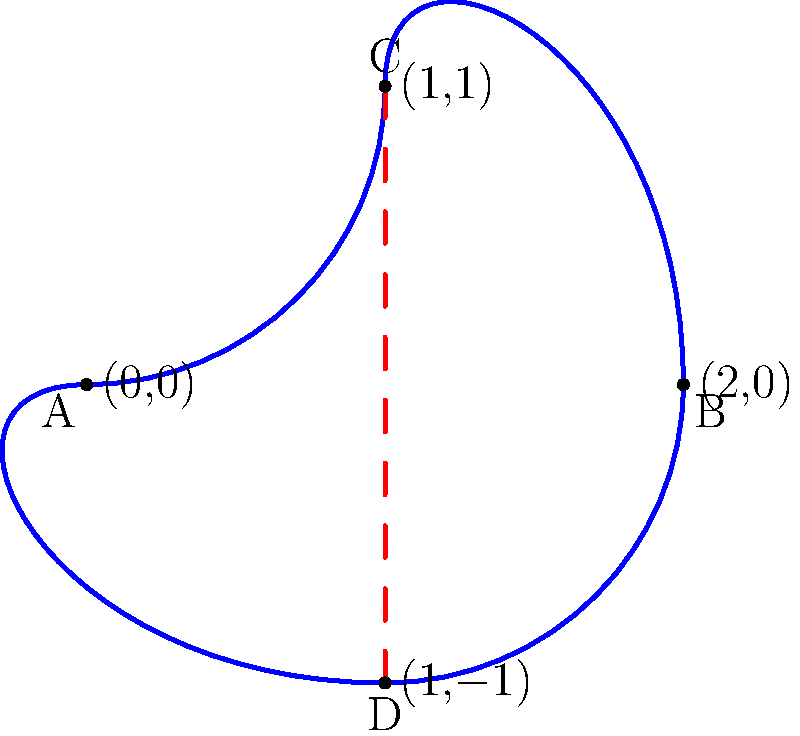In Moroccan literature, the concept of cultural identity is often explored through complex, interconnected narratives. This structure can be likened to a Klein bottle, a non-Euclidean surface without an inside or outside. Consider the 2D projection of a Klein bottle shown above. If we imagine a character's journey through a novel as a path on this surface, starting from point A and traveling clockwise, how many times must they cross the red dashed line to return to their starting point? Relate your answer to the idea of cultural continuity in Moroccan literature. To understand this question, let's break it down step-by-step:

1. The Klein bottle is a non-orientable surface, meaning it has no distinct inside or outside. In the 2D projection, this is represented by the blue curve.

2. The red dashed line represents a "cut" in the surface, which is necessary to represent the Klein bottle in 2D space.

3. Starting from point A and moving clockwise:
   - We move from A to C
   - Cross the red line from C to D (1st crossing)
   - Continue from D to B
   - Move from B to C
   - Cross the red line from C to D again (2nd crossing)
   - Finally, move from D back to A

4. We've crossed the red line twice to complete one full circuit of the Klein bottle.

5. In the context of Moroccan literature, this can be interpreted as follows:
   - The continuous path represents the flow of narrative or cultural identity
   - The crossings represent transitions or transformations in the story or culture
   - The return to the starting point symbolizes the cyclical nature of cultural narratives

6. Just as a character must cross boundaries twice to complete their journey on a Klein bottle, Moroccan literature often explores how individuals navigate cultural boundaries, returning to their roots while being transformed by their experiences.
Answer: 2 crossings; symbolizing cultural transitions and return in Moroccan narratives 